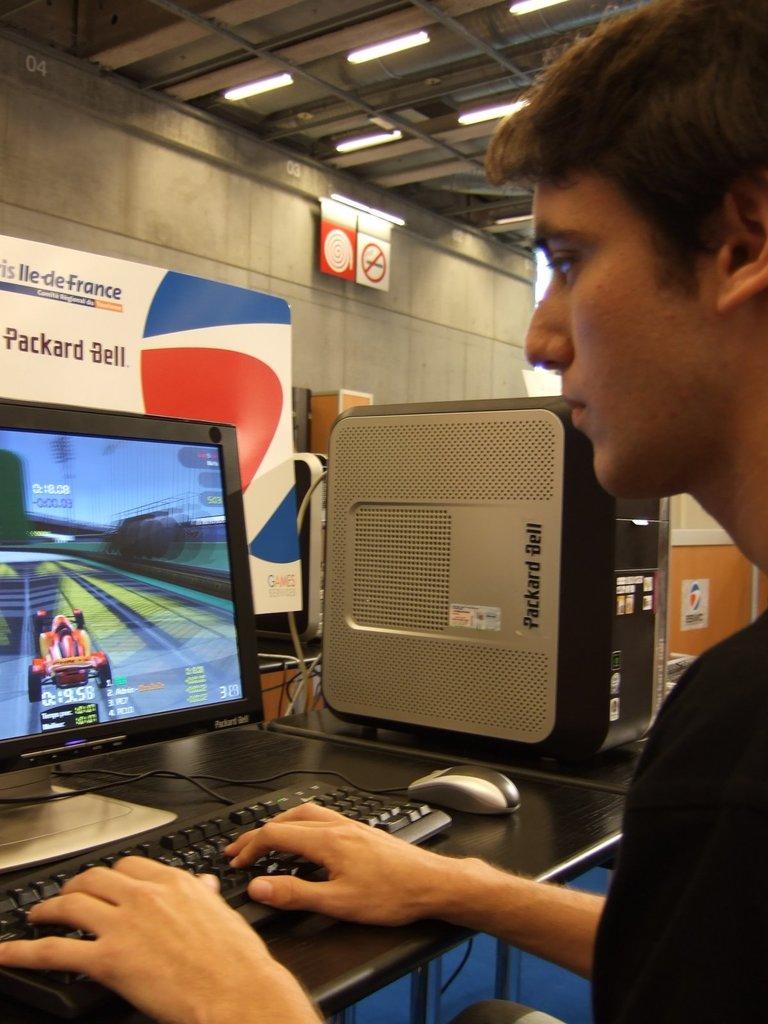What is the brand of computer?
Make the answer very short. Packard bell. What country can be seen listed on the sign behind the computer?
Your response must be concise. France. 